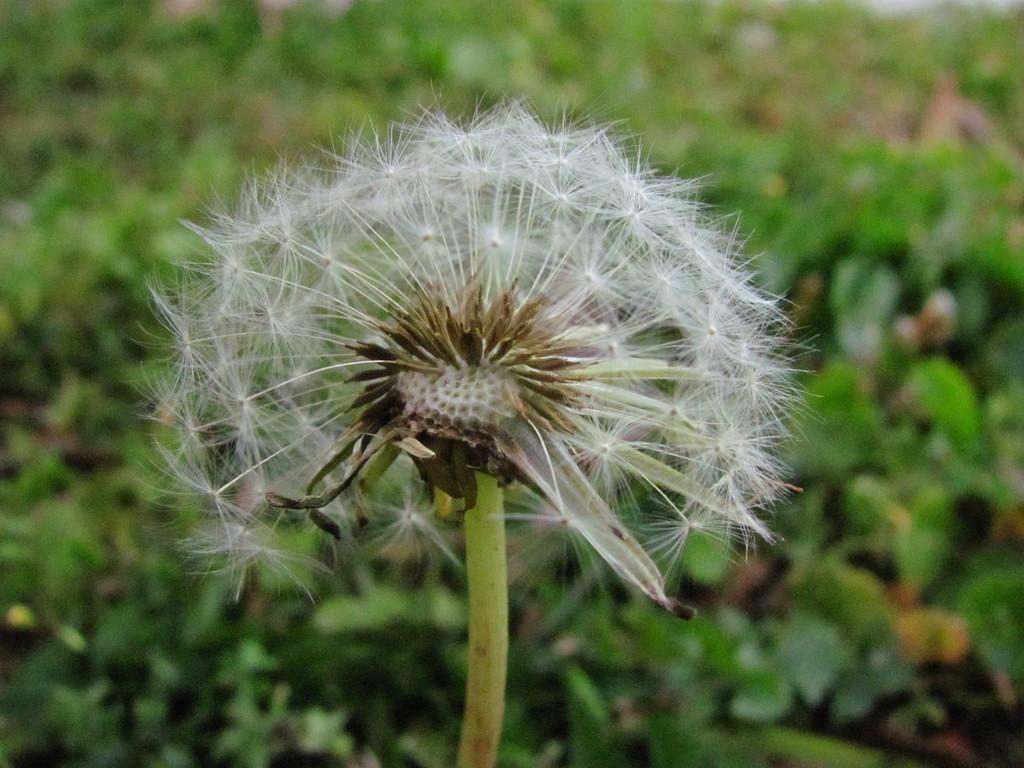Could you give a brief overview of what you see in this image? In this image there are plants, the background of the image is blurred. 